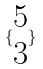Convert formula to latex. <formula><loc_0><loc_0><loc_500><loc_500>\{ \begin{matrix} 5 \\ 3 \end{matrix} \}</formula> 